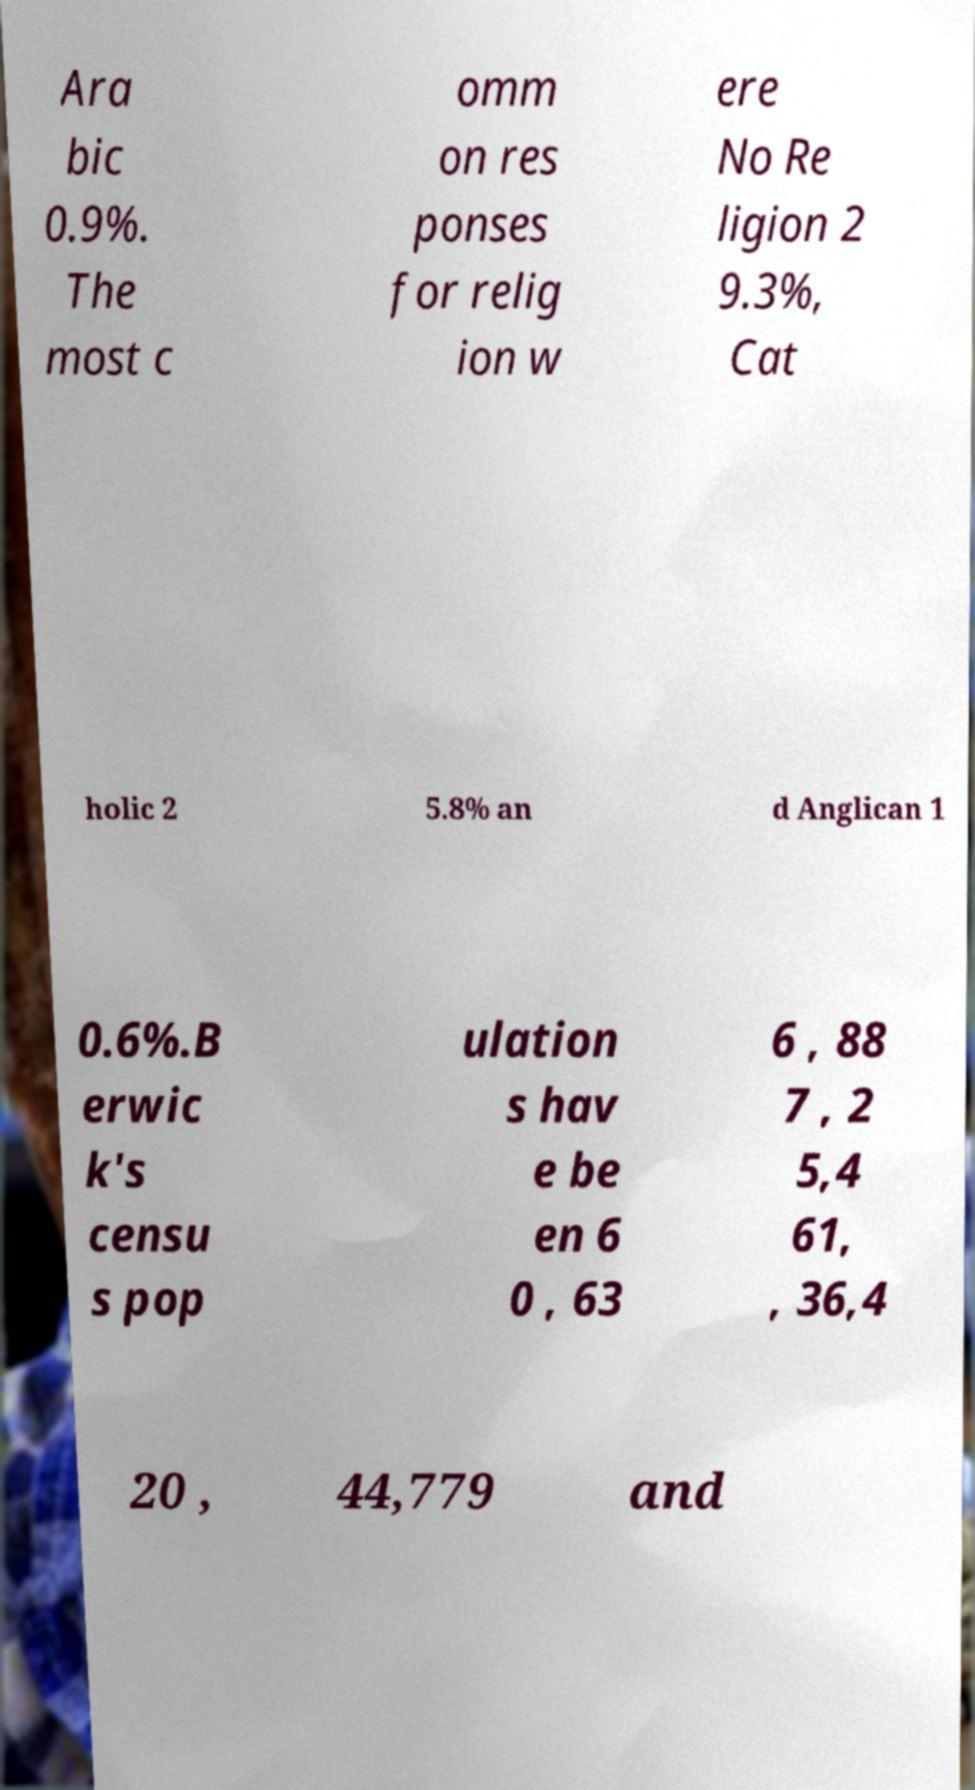Could you extract and type out the text from this image? Ara bic 0.9%. The most c omm on res ponses for relig ion w ere No Re ligion 2 9.3%, Cat holic 2 5.8% an d Anglican 1 0.6%.B erwic k's censu s pop ulation s hav e be en 6 0 , 63 6 , 88 7 , 2 5,4 61, , 36,4 20 , 44,779 and 